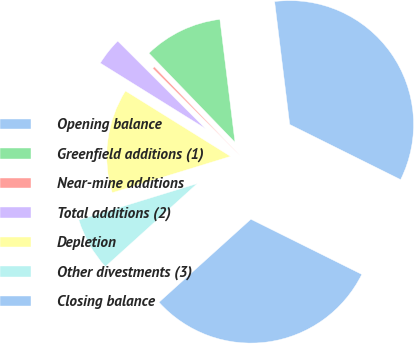Convert chart to OTSL. <chart><loc_0><loc_0><loc_500><loc_500><pie_chart><fcel>Opening balance<fcel>Greenfield additions (1)<fcel>Near-mine additions<fcel>Total additions (2)<fcel>Depletion<fcel>Other divestments (3)<fcel>Closing balance<nl><fcel>34.29%<fcel>10.28%<fcel>0.29%<fcel>3.62%<fcel>13.61%<fcel>6.95%<fcel>30.96%<nl></chart> 